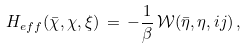Convert formula to latex. <formula><loc_0><loc_0><loc_500><loc_500>H _ { e f f } ( { \bar { \chi } } , \chi , \xi ) \, = \, - \frac { 1 } { \beta } \, { \mathcal { W } } ( { \bar { \eta } } , \eta , i j ) \, ,</formula> 